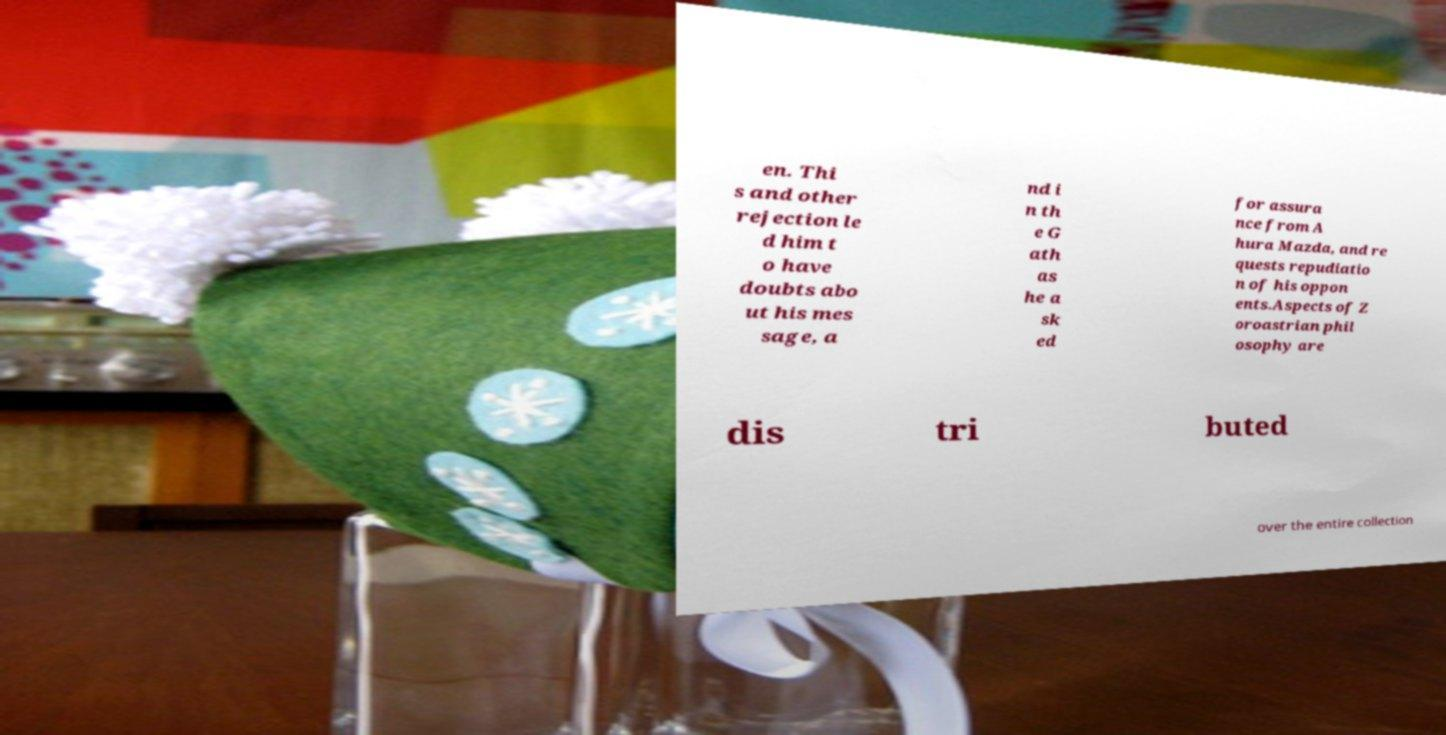Can you accurately transcribe the text from the provided image for me? en. Thi s and other rejection le d him t o have doubts abo ut his mes sage, a nd i n th e G ath as he a sk ed for assura nce from A hura Mazda, and re quests repudiatio n of his oppon ents.Aspects of Z oroastrian phil osophy are dis tri buted over the entire collection 